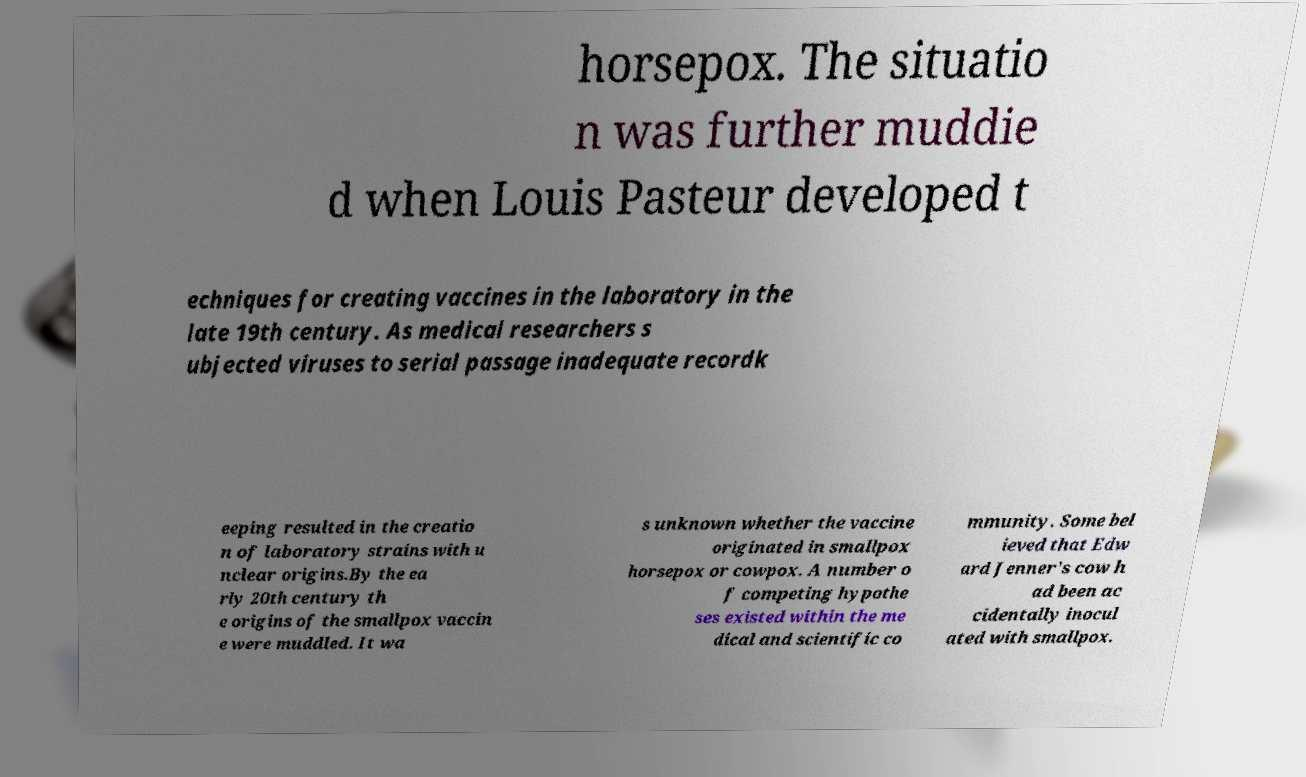Please identify and transcribe the text found in this image. horsepox. The situatio n was further muddie d when Louis Pasteur developed t echniques for creating vaccines in the laboratory in the late 19th century. As medical researchers s ubjected viruses to serial passage inadequate recordk eeping resulted in the creatio n of laboratory strains with u nclear origins.By the ea rly 20th century th e origins of the smallpox vaccin e were muddled. It wa s unknown whether the vaccine originated in smallpox horsepox or cowpox. A number o f competing hypothe ses existed within the me dical and scientific co mmunity. Some bel ieved that Edw ard Jenner's cow h ad been ac cidentally inocul ated with smallpox. 